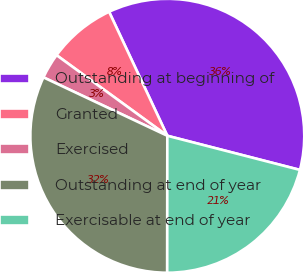Convert chart. <chart><loc_0><loc_0><loc_500><loc_500><pie_chart><fcel>Outstanding at beginning of<fcel>Granted<fcel>Exercised<fcel>Outstanding at end of year<fcel>Exercisable at end of year<nl><fcel>36.0%<fcel>8.0%<fcel>3.0%<fcel>32.0%<fcel>21.0%<nl></chart> 